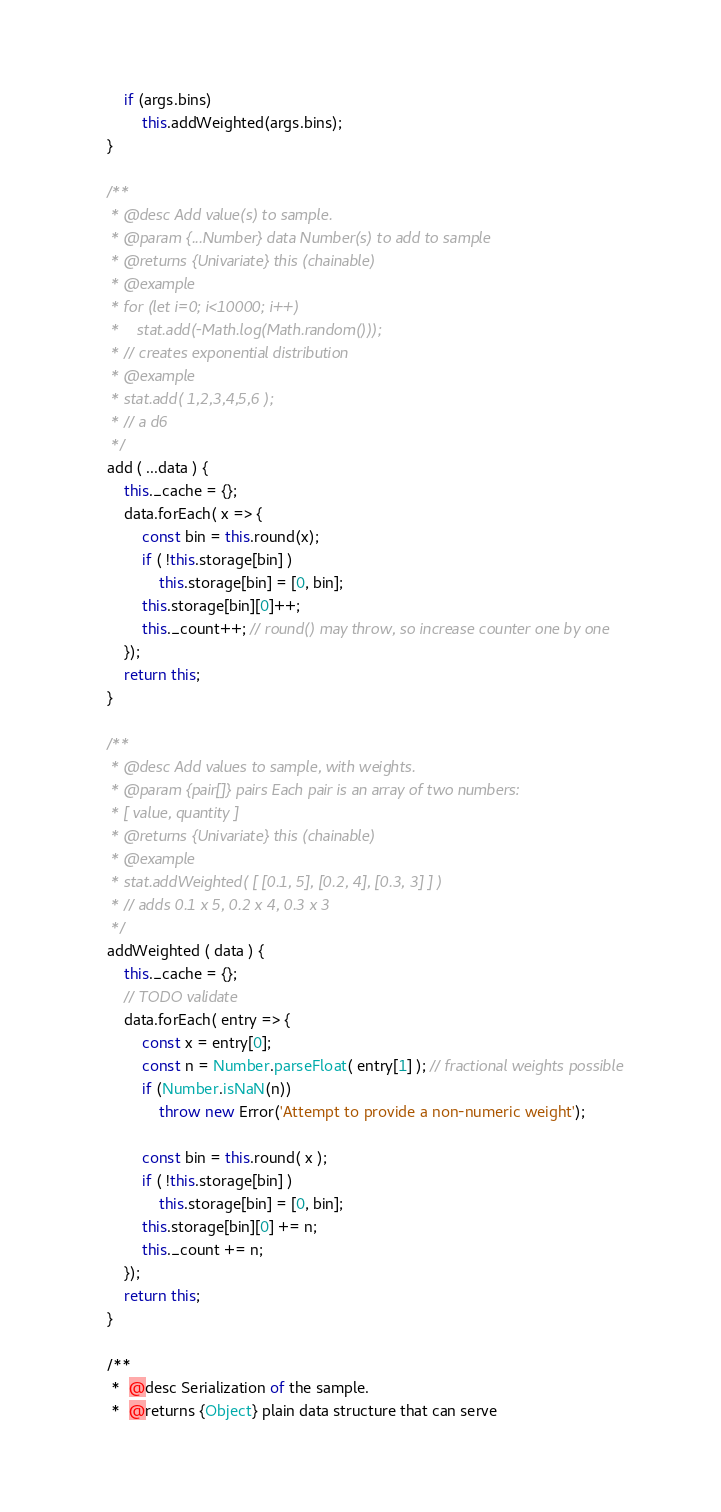Convert code to text. <code><loc_0><loc_0><loc_500><loc_500><_JavaScript_>
        if (args.bins)
            this.addWeighted(args.bins);
    }

    /**
     * @desc Add value(s) to sample.
     * @param {...Number} data Number(s) to add to sample
     * @returns {Univariate} this (chainable)
     * @example
     * for (let i=0; i<10000; i++)
     *    stat.add(-Math.log(Math.random()));
     * // creates exponential distribution
     * @example
     * stat.add( 1,2,3,4,5,6 );
     * // a d6
     */
    add ( ...data ) {
        this._cache = {};
        data.forEach( x => {
            const bin = this.round(x);
            if ( !this.storage[bin] )
                this.storage[bin] = [0, bin];
            this.storage[bin][0]++;
            this._count++; // round() may throw, so increase counter one by one
        });
        return this;
    }

    /**
     * @desc Add values to sample, with weights.
     * @param {pair[]} pairs Each pair is an array of two numbers:
     * [ value, quantity ]
     * @returns {Univariate} this (chainable)
     * @example
     * stat.addWeighted( [ [0.1, 5], [0.2, 4], [0.3, 3] ] )
     * // adds 0.1 x 5, 0.2 x 4, 0.3 x 3
     */
    addWeighted ( data ) {
        this._cache = {};
        // TODO validate
        data.forEach( entry => {
            const x = entry[0];
            const n = Number.parseFloat( entry[1] ); // fractional weights possible
            if (Number.isNaN(n))
                throw new Error('Attempt to provide a non-numeric weight');

            const bin = this.round( x );
            if ( !this.storage[bin] )
                this.storage[bin] = [0, bin];
            this.storage[bin][0] += n;
            this._count += n;
        });
        return this;
    }

    /**
     *  @desc Serialization of the sample.
     *  @returns {Object} plain data structure that can serve</code> 